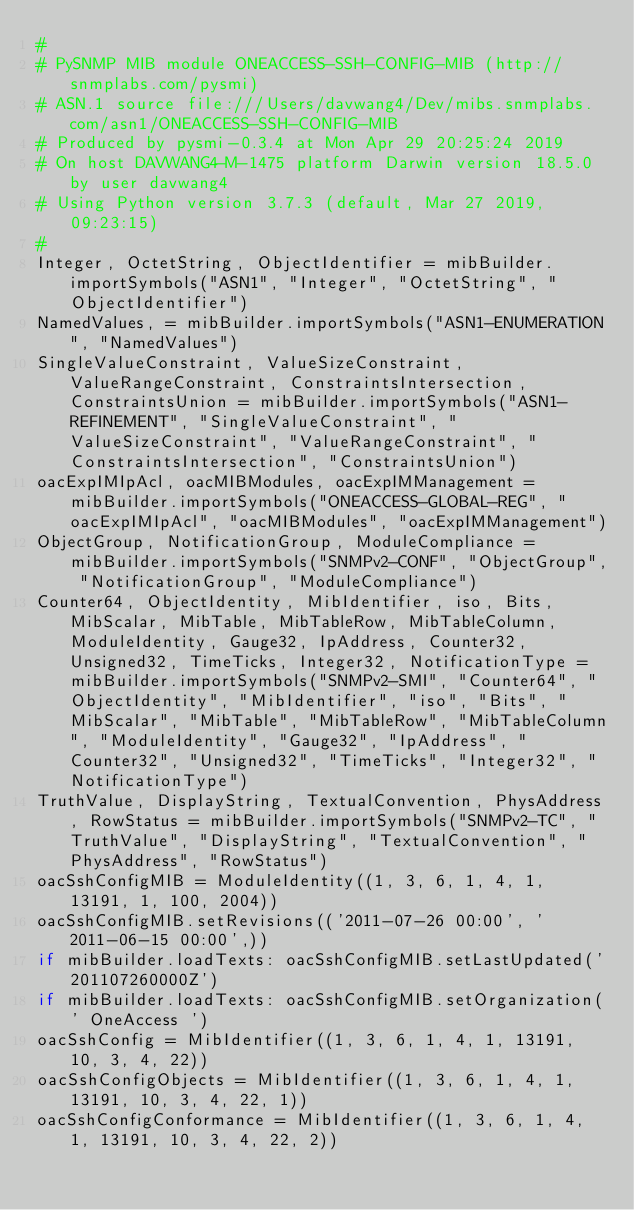Convert code to text. <code><loc_0><loc_0><loc_500><loc_500><_Python_>#
# PySNMP MIB module ONEACCESS-SSH-CONFIG-MIB (http://snmplabs.com/pysmi)
# ASN.1 source file:///Users/davwang4/Dev/mibs.snmplabs.com/asn1/ONEACCESS-SSH-CONFIG-MIB
# Produced by pysmi-0.3.4 at Mon Apr 29 20:25:24 2019
# On host DAVWANG4-M-1475 platform Darwin version 18.5.0 by user davwang4
# Using Python version 3.7.3 (default, Mar 27 2019, 09:23:15) 
#
Integer, OctetString, ObjectIdentifier = mibBuilder.importSymbols("ASN1", "Integer", "OctetString", "ObjectIdentifier")
NamedValues, = mibBuilder.importSymbols("ASN1-ENUMERATION", "NamedValues")
SingleValueConstraint, ValueSizeConstraint, ValueRangeConstraint, ConstraintsIntersection, ConstraintsUnion = mibBuilder.importSymbols("ASN1-REFINEMENT", "SingleValueConstraint", "ValueSizeConstraint", "ValueRangeConstraint", "ConstraintsIntersection", "ConstraintsUnion")
oacExpIMIpAcl, oacMIBModules, oacExpIMManagement = mibBuilder.importSymbols("ONEACCESS-GLOBAL-REG", "oacExpIMIpAcl", "oacMIBModules", "oacExpIMManagement")
ObjectGroup, NotificationGroup, ModuleCompliance = mibBuilder.importSymbols("SNMPv2-CONF", "ObjectGroup", "NotificationGroup", "ModuleCompliance")
Counter64, ObjectIdentity, MibIdentifier, iso, Bits, MibScalar, MibTable, MibTableRow, MibTableColumn, ModuleIdentity, Gauge32, IpAddress, Counter32, Unsigned32, TimeTicks, Integer32, NotificationType = mibBuilder.importSymbols("SNMPv2-SMI", "Counter64", "ObjectIdentity", "MibIdentifier", "iso", "Bits", "MibScalar", "MibTable", "MibTableRow", "MibTableColumn", "ModuleIdentity", "Gauge32", "IpAddress", "Counter32", "Unsigned32", "TimeTicks", "Integer32", "NotificationType")
TruthValue, DisplayString, TextualConvention, PhysAddress, RowStatus = mibBuilder.importSymbols("SNMPv2-TC", "TruthValue", "DisplayString", "TextualConvention", "PhysAddress", "RowStatus")
oacSshConfigMIB = ModuleIdentity((1, 3, 6, 1, 4, 1, 13191, 1, 100, 2004))
oacSshConfigMIB.setRevisions(('2011-07-26 00:00', '2011-06-15 00:00',))
if mibBuilder.loadTexts: oacSshConfigMIB.setLastUpdated('201107260000Z')
if mibBuilder.loadTexts: oacSshConfigMIB.setOrganization(' OneAccess ')
oacSshConfig = MibIdentifier((1, 3, 6, 1, 4, 1, 13191, 10, 3, 4, 22))
oacSshConfigObjects = MibIdentifier((1, 3, 6, 1, 4, 1, 13191, 10, 3, 4, 22, 1))
oacSshConfigConformance = MibIdentifier((1, 3, 6, 1, 4, 1, 13191, 10, 3, 4, 22, 2))</code> 